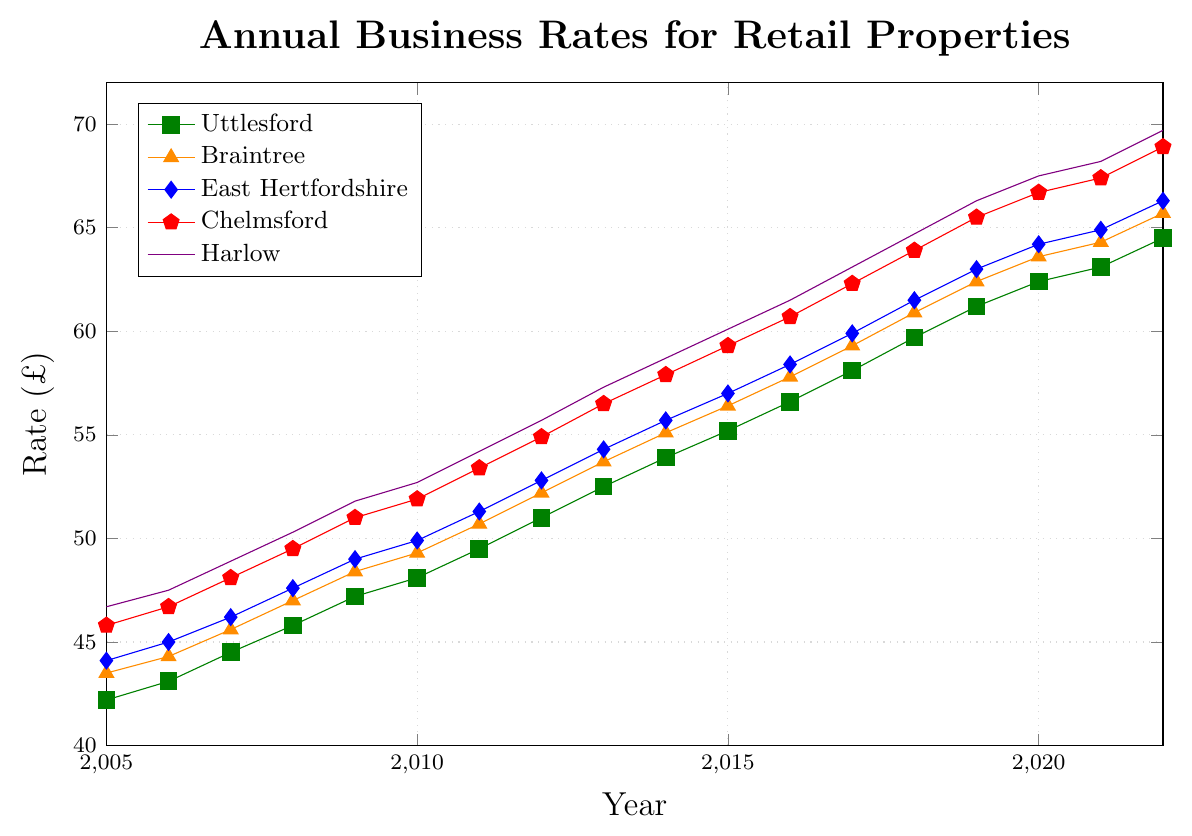Which district had the highest business rate in 2022? From the plot, we see that the line representing Harlow is at the highest position compared to other districts in 2022.
Answer: Harlow What is the rate difference between Uttlesford and East Hertfordshire in 2010? According to the plot, the business rate for Uttlesford in 2010 is 48.1, and for East Hertfordshire, it is 49.9. The difference is 49.9 - 48.1.
Answer: 1.8 By how much did the business rate in Braintree increase from 2005 to 2022? The business rate for Braintree is 43.5 in 2005 and 65.7 in 2022. The increase is calculated by subtracting 43.5 from 65.7.
Answer: 22.2 Which district showed the steepest increase in business rates over the period from 2005 to 2022? By visual inspection, Chelmsford's line has the steepest slope, indicating the highest rate of increase.
Answer: Chelmsford What is the average business rate for Uttlesford from 2005 to 2022? Sum the rates for Uttlesford over the years (42.2 + 43.1 + 44.5 + 45.8 + 47.2 + 48.1 + 49.5 + 51.0 + 52.5 + 53.9 + 55.2 + 56.6 + 58.1 + 59.7 + 61.2 + 62.4 + 63.1 + 64.5) and divide by 18 (the number of years). The sum is 968.6. so the average is 968.6/18.
Answer: 53.81 Which district had the closest business rate to 50 in the year 2012? Based on the graph, Braintree's rate in 2012 is 52.2, East Hertfordshire is 52.8, Chelmsford is 54.9, Harlow is 55.7, and Uttlesford is 51.0. The closest rate to 50 is Uttlesford's.
Answer: Uttlesford In which year did Chelmsford and Harlow first cross the £60 mark? From the graph, for Chelmsford, the line crosses the £60 mark in 2016, and for Harlow, it crosses in 2015.
Answer: Chelmsford: 2016; Harlow: 2015 By how much did the business rate for East Hertfordshire increase between 2008 and 2014? In 2008, the rate for East Hertfordshire was 47.6, and in 2014, it was 55.7. The difference is 55.7 - 47.6.
Answer: 8.1 Which year did all districts have rates above £50? Exploring the plot, the first year all districts crossed the £50 mark is 2011.
Answer: 2011 